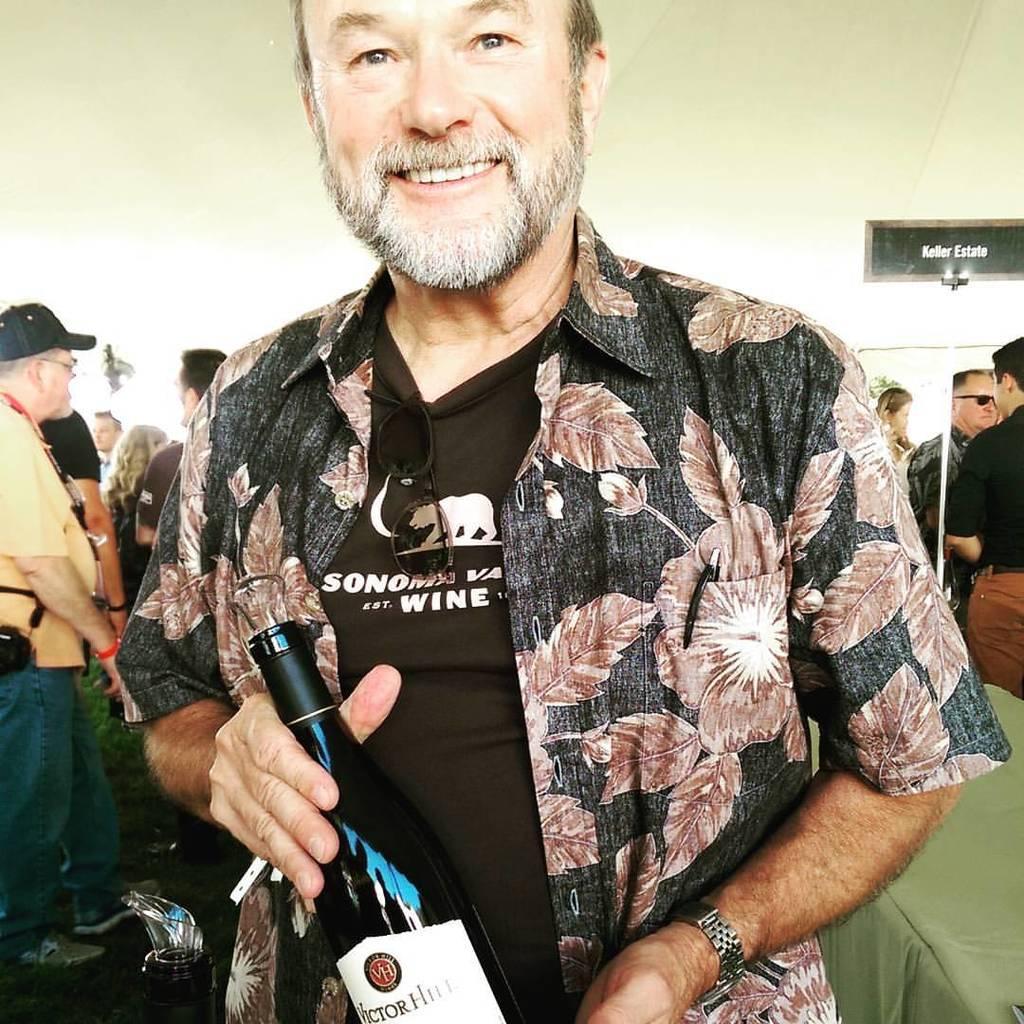In one or two sentences, can you explain what this image depicts? The person is holding a wine bottle in his hands and there are group of people standing behind him. 